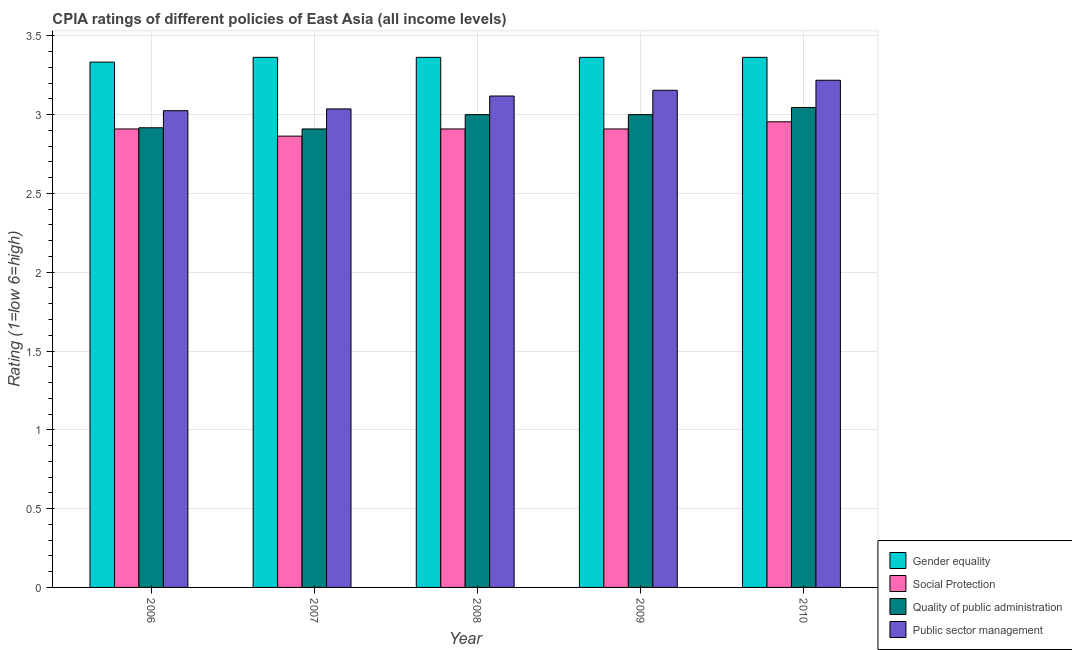How many different coloured bars are there?
Provide a succinct answer. 4. How many groups of bars are there?
Keep it short and to the point. 5. Are the number of bars per tick equal to the number of legend labels?
Ensure brevity in your answer.  Yes. Are the number of bars on each tick of the X-axis equal?
Offer a very short reply. Yes. In how many cases, is the number of bars for a given year not equal to the number of legend labels?
Your answer should be compact. 0. What is the cpia rating of social protection in 2007?
Your answer should be compact. 2.86. Across all years, what is the maximum cpia rating of social protection?
Provide a short and direct response. 2.95. Across all years, what is the minimum cpia rating of public sector management?
Offer a terse response. 3.02. What is the total cpia rating of gender equality in the graph?
Ensure brevity in your answer.  16.79. What is the difference between the cpia rating of social protection in 2006 and that in 2008?
Your response must be concise. 0. What is the difference between the cpia rating of social protection in 2010 and the cpia rating of quality of public administration in 2009?
Ensure brevity in your answer.  0.05. What is the average cpia rating of gender equality per year?
Keep it short and to the point. 3.36. In the year 2007, what is the difference between the cpia rating of public sector management and cpia rating of social protection?
Ensure brevity in your answer.  0. What is the ratio of the cpia rating of social protection in 2006 to that in 2010?
Give a very brief answer. 0.98. Is the cpia rating of gender equality in 2007 less than that in 2010?
Offer a terse response. No. What is the difference between the highest and the second highest cpia rating of gender equality?
Your response must be concise. 0. What is the difference between the highest and the lowest cpia rating of public sector management?
Your answer should be very brief. 0.19. Is the sum of the cpia rating of quality of public administration in 2008 and 2009 greater than the maximum cpia rating of social protection across all years?
Keep it short and to the point. Yes. What does the 1st bar from the left in 2008 represents?
Provide a succinct answer. Gender equality. What does the 1st bar from the right in 2009 represents?
Keep it short and to the point. Public sector management. How many bars are there?
Offer a terse response. 20. What is the difference between two consecutive major ticks on the Y-axis?
Offer a very short reply. 0.5. Does the graph contain grids?
Offer a very short reply. Yes. Where does the legend appear in the graph?
Ensure brevity in your answer.  Bottom right. How are the legend labels stacked?
Give a very brief answer. Vertical. What is the title of the graph?
Provide a succinct answer. CPIA ratings of different policies of East Asia (all income levels). Does "Secondary general education" appear as one of the legend labels in the graph?
Make the answer very short. No. What is the Rating (1=low 6=high) of Gender equality in 2006?
Make the answer very short. 3.33. What is the Rating (1=low 6=high) in Social Protection in 2006?
Offer a very short reply. 2.91. What is the Rating (1=low 6=high) in Quality of public administration in 2006?
Your response must be concise. 2.92. What is the Rating (1=low 6=high) of Public sector management in 2006?
Ensure brevity in your answer.  3.02. What is the Rating (1=low 6=high) of Gender equality in 2007?
Offer a terse response. 3.36. What is the Rating (1=low 6=high) of Social Protection in 2007?
Your response must be concise. 2.86. What is the Rating (1=low 6=high) in Quality of public administration in 2007?
Provide a succinct answer. 2.91. What is the Rating (1=low 6=high) of Public sector management in 2007?
Make the answer very short. 3.04. What is the Rating (1=low 6=high) in Gender equality in 2008?
Your answer should be very brief. 3.36. What is the Rating (1=low 6=high) in Social Protection in 2008?
Offer a terse response. 2.91. What is the Rating (1=low 6=high) of Quality of public administration in 2008?
Your answer should be very brief. 3. What is the Rating (1=low 6=high) of Public sector management in 2008?
Provide a short and direct response. 3.12. What is the Rating (1=low 6=high) in Gender equality in 2009?
Provide a succinct answer. 3.36. What is the Rating (1=low 6=high) of Social Protection in 2009?
Keep it short and to the point. 2.91. What is the Rating (1=low 6=high) in Quality of public administration in 2009?
Your response must be concise. 3. What is the Rating (1=low 6=high) in Public sector management in 2009?
Your response must be concise. 3.15. What is the Rating (1=low 6=high) of Gender equality in 2010?
Offer a very short reply. 3.36. What is the Rating (1=low 6=high) in Social Protection in 2010?
Provide a succinct answer. 2.95. What is the Rating (1=low 6=high) in Quality of public administration in 2010?
Provide a succinct answer. 3.05. What is the Rating (1=low 6=high) of Public sector management in 2010?
Keep it short and to the point. 3.22. Across all years, what is the maximum Rating (1=low 6=high) in Gender equality?
Give a very brief answer. 3.36. Across all years, what is the maximum Rating (1=low 6=high) in Social Protection?
Make the answer very short. 2.95. Across all years, what is the maximum Rating (1=low 6=high) in Quality of public administration?
Ensure brevity in your answer.  3.05. Across all years, what is the maximum Rating (1=low 6=high) in Public sector management?
Your answer should be compact. 3.22. Across all years, what is the minimum Rating (1=low 6=high) in Gender equality?
Make the answer very short. 3.33. Across all years, what is the minimum Rating (1=low 6=high) in Social Protection?
Keep it short and to the point. 2.86. Across all years, what is the minimum Rating (1=low 6=high) of Quality of public administration?
Ensure brevity in your answer.  2.91. Across all years, what is the minimum Rating (1=low 6=high) in Public sector management?
Offer a terse response. 3.02. What is the total Rating (1=low 6=high) of Gender equality in the graph?
Offer a terse response. 16.79. What is the total Rating (1=low 6=high) in Social Protection in the graph?
Ensure brevity in your answer.  14.55. What is the total Rating (1=low 6=high) of Quality of public administration in the graph?
Your answer should be compact. 14.87. What is the total Rating (1=low 6=high) of Public sector management in the graph?
Make the answer very short. 15.55. What is the difference between the Rating (1=low 6=high) in Gender equality in 2006 and that in 2007?
Your answer should be very brief. -0.03. What is the difference between the Rating (1=low 6=high) of Social Protection in 2006 and that in 2007?
Provide a short and direct response. 0.05. What is the difference between the Rating (1=low 6=high) in Quality of public administration in 2006 and that in 2007?
Provide a short and direct response. 0.01. What is the difference between the Rating (1=low 6=high) in Public sector management in 2006 and that in 2007?
Your answer should be very brief. -0.01. What is the difference between the Rating (1=low 6=high) in Gender equality in 2006 and that in 2008?
Make the answer very short. -0.03. What is the difference between the Rating (1=low 6=high) in Quality of public administration in 2006 and that in 2008?
Give a very brief answer. -0.08. What is the difference between the Rating (1=low 6=high) in Public sector management in 2006 and that in 2008?
Provide a succinct answer. -0.09. What is the difference between the Rating (1=low 6=high) in Gender equality in 2006 and that in 2009?
Provide a short and direct response. -0.03. What is the difference between the Rating (1=low 6=high) in Quality of public administration in 2006 and that in 2009?
Your response must be concise. -0.08. What is the difference between the Rating (1=low 6=high) in Public sector management in 2006 and that in 2009?
Give a very brief answer. -0.13. What is the difference between the Rating (1=low 6=high) in Gender equality in 2006 and that in 2010?
Make the answer very short. -0.03. What is the difference between the Rating (1=low 6=high) in Social Protection in 2006 and that in 2010?
Your answer should be compact. -0.05. What is the difference between the Rating (1=low 6=high) in Quality of public administration in 2006 and that in 2010?
Provide a short and direct response. -0.13. What is the difference between the Rating (1=low 6=high) of Public sector management in 2006 and that in 2010?
Your answer should be very brief. -0.19. What is the difference between the Rating (1=low 6=high) in Gender equality in 2007 and that in 2008?
Make the answer very short. 0. What is the difference between the Rating (1=low 6=high) in Social Protection in 2007 and that in 2008?
Your answer should be very brief. -0.05. What is the difference between the Rating (1=low 6=high) of Quality of public administration in 2007 and that in 2008?
Ensure brevity in your answer.  -0.09. What is the difference between the Rating (1=low 6=high) of Public sector management in 2007 and that in 2008?
Offer a terse response. -0.08. What is the difference between the Rating (1=low 6=high) of Social Protection in 2007 and that in 2009?
Offer a terse response. -0.05. What is the difference between the Rating (1=low 6=high) in Quality of public administration in 2007 and that in 2009?
Offer a terse response. -0.09. What is the difference between the Rating (1=low 6=high) in Public sector management in 2007 and that in 2009?
Offer a very short reply. -0.12. What is the difference between the Rating (1=low 6=high) in Gender equality in 2007 and that in 2010?
Provide a succinct answer. 0. What is the difference between the Rating (1=low 6=high) in Social Protection in 2007 and that in 2010?
Your answer should be very brief. -0.09. What is the difference between the Rating (1=low 6=high) of Quality of public administration in 2007 and that in 2010?
Make the answer very short. -0.14. What is the difference between the Rating (1=low 6=high) of Public sector management in 2007 and that in 2010?
Your answer should be compact. -0.18. What is the difference between the Rating (1=low 6=high) in Gender equality in 2008 and that in 2009?
Provide a short and direct response. 0. What is the difference between the Rating (1=low 6=high) of Social Protection in 2008 and that in 2009?
Offer a very short reply. 0. What is the difference between the Rating (1=low 6=high) of Public sector management in 2008 and that in 2009?
Provide a short and direct response. -0.04. What is the difference between the Rating (1=low 6=high) in Gender equality in 2008 and that in 2010?
Keep it short and to the point. 0. What is the difference between the Rating (1=low 6=high) in Social Protection in 2008 and that in 2010?
Make the answer very short. -0.05. What is the difference between the Rating (1=low 6=high) in Quality of public administration in 2008 and that in 2010?
Give a very brief answer. -0.05. What is the difference between the Rating (1=low 6=high) in Public sector management in 2008 and that in 2010?
Provide a short and direct response. -0.1. What is the difference between the Rating (1=low 6=high) of Gender equality in 2009 and that in 2010?
Your response must be concise. 0. What is the difference between the Rating (1=low 6=high) of Social Protection in 2009 and that in 2010?
Provide a succinct answer. -0.05. What is the difference between the Rating (1=low 6=high) of Quality of public administration in 2009 and that in 2010?
Offer a very short reply. -0.05. What is the difference between the Rating (1=low 6=high) in Public sector management in 2009 and that in 2010?
Provide a short and direct response. -0.06. What is the difference between the Rating (1=low 6=high) in Gender equality in 2006 and the Rating (1=low 6=high) in Social Protection in 2007?
Make the answer very short. 0.47. What is the difference between the Rating (1=low 6=high) of Gender equality in 2006 and the Rating (1=low 6=high) of Quality of public administration in 2007?
Offer a very short reply. 0.42. What is the difference between the Rating (1=low 6=high) of Gender equality in 2006 and the Rating (1=low 6=high) of Public sector management in 2007?
Provide a succinct answer. 0.3. What is the difference between the Rating (1=low 6=high) of Social Protection in 2006 and the Rating (1=low 6=high) of Quality of public administration in 2007?
Offer a terse response. 0. What is the difference between the Rating (1=low 6=high) in Social Protection in 2006 and the Rating (1=low 6=high) in Public sector management in 2007?
Keep it short and to the point. -0.13. What is the difference between the Rating (1=low 6=high) of Quality of public administration in 2006 and the Rating (1=low 6=high) of Public sector management in 2007?
Your answer should be very brief. -0.12. What is the difference between the Rating (1=low 6=high) of Gender equality in 2006 and the Rating (1=low 6=high) of Social Protection in 2008?
Ensure brevity in your answer.  0.42. What is the difference between the Rating (1=low 6=high) in Gender equality in 2006 and the Rating (1=low 6=high) in Quality of public administration in 2008?
Give a very brief answer. 0.33. What is the difference between the Rating (1=low 6=high) of Gender equality in 2006 and the Rating (1=low 6=high) of Public sector management in 2008?
Give a very brief answer. 0.22. What is the difference between the Rating (1=low 6=high) in Social Protection in 2006 and the Rating (1=low 6=high) in Quality of public administration in 2008?
Your answer should be very brief. -0.09. What is the difference between the Rating (1=low 6=high) of Social Protection in 2006 and the Rating (1=low 6=high) of Public sector management in 2008?
Make the answer very short. -0.21. What is the difference between the Rating (1=low 6=high) in Quality of public administration in 2006 and the Rating (1=low 6=high) in Public sector management in 2008?
Your response must be concise. -0.2. What is the difference between the Rating (1=low 6=high) in Gender equality in 2006 and the Rating (1=low 6=high) in Social Protection in 2009?
Your answer should be compact. 0.42. What is the difference between the Rating (1=low 6=high) of Gender equality in 2006 and the Rating (1=low 6=high) of Public sector management in 2009?
Your answer should be compact. 0.18. What is the difference between the Rating (1=low 6=high) in Social Protection in 2006 and the Rating (1=low 6=high) in Quality of public administration in 2009?
Offer a terse response. -0.09. What is the difference between the Rating (1=low 6=high) of Social Protection in 2006 and the Rating (1=low 6=high) of Public sector management in 2009?
Your response must be concise. -0.25. What is the difference between the Rating (1=low 6=high) in Quality of public administration in 2006 and the Rating (1=low 6=high) in Public sector management in 2009?
Your response must be concise. -0.24. What is the difference between the Rating (1=low 6=high) in Gender equality in 2006 and the Rating (1=low 6=high) in Social Protection in 2010?
Your response must be concise. 0.38. What is the difference between the Rating (1=low 6=high) in Gender equality in 2006 and the Rating (1=low 6=high) in Quality of public administration in 2010?
Your answer should be compact. 0.29. What is the difference between the Rating (1=low 6=high) in Gender equality in 2006 and the Rating (1=low 6=high) in Public sector management in 2010?
Offer a very short reply. 0.12. What is the difference between the Rating (1=low 6=high) of Social Protection in 2006 and the Rating (1=low 6=high) of Quality of public administration in 2010?
Make the answer very short. -0.14. What is the difference between the Rating (1=low 6=high) of Social Protection in 2006 and the Rating (1=low 6=high) of Public sector management in 2010?
Your answer should be very brief. -0.31. What is the difference between the Rating (1=low 6=high) in Quality of public administration in 2006 and the Rating (1=low 6=high) in Public sector management in 2010?
Your answer should be very brief. -0.3. What is the difference between the Rating (1=low 6=high) in Gender equality in 2007 and the Rating (1=low 6=high) in Social Protection in 2008?
Provide a succinct answer. 0.45. What is the difference between the Rating (1=low 6=high) of Gender equality in 2007 and the Rating (1=low 6=high) of Quality of public administration in 2008?
Ensure brevity in your answer.  0.36. What is the difference between the Rating (1=low 6=high) of Gender equality in 2007 and the Rating (1=low 6=high) of Public sector management in 2008?
Your answer should be compact. 0.25. What is the difference between the Rating (1=low 6=high) of Social Protection in 2007 and the Rating (1=low 6=high) of Quality of public administration in 2008?
Keep it short and to the point. -0.14. What is the difference between the Rating (1=low 6=high) in Social Protection in 2007 and the Rating (1=low 6=high) in Public sector management in 2008?
Make the answer very short. -0.25. What is the difference between the Rating (1=low 6=high) in Quality of public administration in 2007 and the Rating (1=low 6=high) in Public sector management in 2008?
Offer a very short reply. -0.21. What is the difference between the Rating (1=low 6=high) of Gender equality in 2007 and the Rating (1=low 6=high) of Social Protection in 2009?
Keep it short and to the point. 0.45. What is the difference between the Rating (1=low 6=high) of Gender equality in 2007 and the Rating (1=low 6=high) of Quality of public administration in 2009?
Your response must be concise. 0.36. What is the difference between the Rating (1=low 6=high) in Gender equality in 2007 and the Rating (1=low 6=high) in Public sector management in 2009?
Your answer should be compact. 0.21. What is the difference between the Rating (1=low 6=high) in Social Protection in 2007 and the Rating (1=low 6=high) in Quality of public administration in 2009?
Offer a very short reply. -0.14. What is the difference between the Rating (1=low 6=high) of Social Protection in 2007 and the Rating (1=low 6=high) of Public sector management in 2009?
Offer a very short reply. -0.29. What is the difference between the Rating (1=low 6=high) of Quality of public administration in 2007 and the Rating (1=low 6=high) of Public sector management in 2009?
Provide a short and direct response. -0.25. What is the difference between the Rating (1=low 6=high) of Gender equality in 2007 and the Rating (1=low 6=high) of Social Protection in 2010?
Provide a short and direct response. 0.41. What is the difference between the Rating (1=low 6=high) of Gender equality in 2007 and the Rating (1=low 6=high) of Quality of public administration in 2010?
Ensure brevity in your answer.  0.32. What is the difference between the Rating (1=low 6=high) in Gender equality in 2007 and the Rating (1=low 6=high) in Public sector management in 2010?
Keep it short and to the point. 0.15. What is the difference between the Rating (1=low 6=high) in Social Protection in 2007 and the Rating (1=low 6=high) in Quality of public administration in 2010?
Keep it short and to the point. -0.18. What is the difference between the Rating (1=low 6=high) of Social Protection in 2007 and the Rating (1=low 6=high) of Public sector management in 2010?
Your answer should be compact. -0.35. What is the difference between the Rating (1=low 6=high) in Quality of public administration in 2007 and the Rating (1=low 6=high) in Public sector management in 2010?
Offer a terse response. -0.31. What is the difference between the Rating (1=low 6=high) of Gender equality in 2008 and the Rating (1=low 6=high) of Social Protection in 2009?
Give a very brief answer. 0.45. What is the difference between the Rating (1=low 6=high) of Gender equality in 2008 and the Rating (1=low 6=high) of Quality of public administration in 2009?
Provide a succinct answer. 0.36. What is the difference between the Rating (1=low 6=high) of Gender equality in 2008 and the Rating (1=low 6=high) of Public sector management in 2009?
Keep it short and to the point. 0.21. What is the difference between the Rating (1=low 6=high) in Social Protection in 2008 and the Rating (1=low 6=high) in Quality of public administration in 2009?
Offer a terse response. -0.09. What is the difference between the Rating (1=low 6=high) of Social Protection in 2008 and the Rating (1=low 6=high) of Public sector management in 2009?
Your answer should be compact. -0.25. What is the difference between the Rating (1=low 6=high) in Quality of public administration in 2008 and the Rating (1=low 6=high) in Public sector management in 2009?
Ensure brevity in your answer.  -0.15. What is the difference between the Rating (1=low 6=high) in Gender equality in 2008 and the Rating (1=low 6=high) in Social Protection in 2010?
Provide a short and direct response. 0.41. What is the difference between the Rating (1=low 6=high) in Gender equality in 2008 and the Rating (1=low 6=high) in Quality of public administration in 2010?
Give a very brief answer. 0.32. What is the difference between the Rating (1=low 6=high) of Gender equality in 2008 and the Rating (1=low 6=high) of Public sector management in 2010?
Your answer should be compact. 0.15. What is the difference between the Rating (1=low 6=high) of Social Protection in 2008 and the Rating (1=low 6=high) of Quality of public administration in 2010?
Keep it short and to the point. -0.14. What is the difference between the Rating (1=low 6=high) of Social Protection in 2008 and the Rating (1=low 6=high) of Public sector management in 2010?
Offer a terse response. -0.31. What is the difference between the Rating (1=low 6=high) in Quality of public administration in 2008 and the Rating (1=low 6=high) in Public sector management in 2010?
Your answer should be very brief. -0.22. What is the difference between the Rating (1=low 6=high) of Gender equality in 2009 and the Rating (1=low 6=high) of Social Protection in 2010?
Make the answer very short. 0.41. What is the difference between the Rating (1=low 6=high) in Gender equality in 2009 and the Rating (1=low 6=high) in Quality of public administration in 2010?
Your answer should be compact. 0.32. What is the difference between the Rating (1=low 6=high) of Gender equality in 2009 and the Rating (1=low 6=high) of Public sector management in 2010?
Your response must be concise. 0.15. What is the difference between the Rating (1=low 6=high) of Social Protection in 2009 and the Rating (1=low 6=high) of Quality of public administration in 2010?
Give a very brief answer. -0.14. What is the difference between the Rating (1=low 6=high) in Social Protection in 2009 and the Rating (1=low 6=high) in Public sector management in 2010?
Your answer should be compact. -0.31. What is the difference between the Rating (1=low 6=high) of Quality of public administration in 2009 and the Rating (1=low 6=high) of Public sector management in 2010?
Ensure brevity in your answer.  -0.22. What is the average Rating (1=low 6=high) in Gender equality per year?
Make the answer very short. 3.36. What is the average Rating (1=low 6=high) of Social Protection per year?
Offer a very short reply. 2.91. What is the average Rating (1=low 6=high) of Quality of public administration per year?
Ensure brevity in your answer.  2.97. What is the average Rating (1=low 6=high) in Public sector management per year?
Your answer should be compact. 3.11. In the year 2006, what is the difference between the Rating (1=low 6=high) of Gender equality and Rating (1=low 6=high) of Social Protection?
Ensure brevity in your answer.  0.42. In the year 2006, what is the difference between the Rating (1=low 6=high) of Gender equality and Rating (1=low 6=high) of Quality of public administration?
Give a very brief answer. 0.42. In the year 2006, what is the difference between the Rating (1=low 6=high) in Gender equality and Rating (1=low 6=high) in Public sector management?
Your answer should be very brief. 0.31. In the year 2006, what is the difference between the Rating (1=low 6=high) of Social Protection and Rating (1=low 6=high) of Quality of public administration?
Give a very brief answer. -0.01. In the year 2006, what is the difference between the Rating (1=low 6=high) in Social Protection and Rating (1=low 6=high) in Public sector management?
Keep it short and to the point. -0.12. In the year 2006, what is the difference between the Rating (1=low 6=high) in Quality of public administration and Rating (1=low 6=high) in Public sector management?
Your response must be concise. -0.11. In the year 2007, what is the difference between the Rating (1=low 6=high) in Gender equality and Rating (1=low 6=high) in Social Protection?
Ensure brevity in your answer.  0.5. In the year 2007, what is the difference between the Rating (1=low 6=high) in Gender equality and Rating (1=low 6=high) in Quality of public administration?
Ensure brevity in your answer.  0.45. In the year 2007, what is the difference between the Rating (1=low 6=high) of Gender equality and Rating (1=low 6=high) of Public sector management?
Make the answer very short. 0.33. In the year 2007, what is the difference between the Rating (1=low 6=high) in Social Protection and Rating (1=low 6=high) in Quality of public administration?
Your answer should be very brief. -0.05. In the year 2007, what is the difference between the Rating (1=low 6=high) in Social Protection and Rating (1=low 6=high) in Public sector management?
Provide a succinct answer. -0.17. In the year 2007, what is the difference between the Rating (1=low 6=high) of Quality of public administration and Rating (1=low 6=high) of Public sector management?
Your answer should be compact. -0.13. In the year 2008, what is the difference between the Rating (1=low 6=high) in Gender equality and Rating (1=low 6=high) in Social Protection?
Keep it short and to the point. 0.45. In the year 2008, what is the difference between the Rating (1=low 6=high) in Gender equality and Rating (1=low 6=high) in Quality of public administration?
Your response must be concise. 0.36. In the year 2008, what is the difference between the Rating (1=low 6=high) of Gender equality and Rating (1=low 6=high) of Public sector management?
Provide a short and direct response. 0.25. In the year 2008, what is the difference between the Rating (1=low 6=high) in Social Protection and Rating (1=low 6=high) in Quality of public administration?
Provide a short and direct response. -0.09. In the year 2008, what is the difference between the Rating (1=low 6=high) in Social Protection and Rating (1=low 6=high) in Public sector management?
Your response must be concise. -0.21. In the year 2008, what is the difference between the Rating (1=low 6=high) in Quality of public administration and Rating (1=low 6=high) in Public sector management?
Your answer should be very brief. -0.12. In the year 2009, what is the difference between the Rating (1=low 6=high) in Gender equality and Rating (1=low 6=high) in Social Protection?
Offer a very short reply. 0.45. In the year 2009, what is the difference between the Rating (1=low 6=high) in Gender equality and Rating (1=low 6=high) in Quality of public administration?
Make the answer very short. 0.36. In the year 2009, what is the difference between the Rating (1=low 6=high) of Gender equality and Rating (1=low 6=high) of Public sector management?
Keep it short and to the point. 0.21. In the year 2009, what is the difference between the Rating (1=low 6=high) of Social Protection and Rating (1=low 6=high) of Quality of public administration?
Your response must be concise. -0.09. In the year 2009, what is the difference between the Rating (1=low 6=high) of Social Protection and Rating (1=low 6=high) of Public sector management?
Your response must be concise. -0.25. In the year 2009, what is the difference between the Rating (1=low 6=high) of Quality of public administration and Rating (1=low 6=high) of Public sector management?
Offer a terse response. -0.15. In the year 2010, what is the difference between the Rating (1=low 6=high) of Gender equality and Rating (1=low 6=high) of Social Protection?
Make the answer very short. 0.41. In the year 2010, what is the difference between the Rating (1=low 6=high) in Gender equality and Rating (1=low 6=high) in Quality of public administration?
Make the answer very short. 0.32. In the year 2010, what is the difference between the Rating (1=low 6=high) in Gender equality and Rating (1=low 6=high) in Public sector management?
Provide a short and direct response. 0.15. In the year 2010, what is the difference between the Rating (1=low 6=high) in Social Protection and Rating (1=low 6=high) in Quality of public administration?
Provide a succinct answer. -0.09. In the year 2010, what is the difference between the Rating (1=low 6=high) in Social Protection and Rating (1=low 6=high) in Public sector management?
Offer a terse response. -0.26. In the year 2010, what is the difference between the Rating (1=low 6=high) of Quality of public administration and Rating (1=low 6=high) of Public sector management?
Provide a short and direct response. -0.17. What is the ratio of the Rating (1=low 6=high) in Gender equality in 2006 to that in 2007?
Offer a terse response. 0.99. What is the ratio of the Rating (1=low 6=high) in Social Protection in 2006 to that in 2007?
Ensure brevity in your answer.  1.02. What is the ratio of the Rating (1=low 6=high) in Quality of public administration in 2006 to that in 2007?
Provide a short and direct response. 1. What is the ratio of the Rating (1=low 6=high) in Quality of public administration in 2006 to that in 2008?
Your response must be concise. 0.97. What is the ratio of the Rating (1=low 6=high) in Public sector management in 2006 to that in 2008?
Your answer should be very brief. 0.97. What is the ratio of the Rating (1=low 6=high) of Quality of public administration in 2006 to that in 2009?
Give a very brief answer. 0.97. What is the ratio of the Rating (1=low 6=high) of Public sector management in 2006 to that in 2009?
Your answer should be compact. 0.96. What is the ratio of the Rating (1=low 6=high) in Gender equality in 2006 to that in 2010?
Ensure brevity in your answer.  0.99. What is the ratio of the Rating (1=low 6=high) in Social Protection in 2006 to that in 2010?
Provide a short and direct response. 0.98. What is the ratio of the Rating (1=low 6=high) in Quality of public administration in 2006 to that in 2010?
Provide a succinct answer. 0.96. What is the ratio of the Rating (1=low 6=high) in Public sector management in 2006 to that in 2010?
Ensure brevity in your answer.  0.94. What is the ratio of the Rating (1=low 6=high) of Social Protection in 2007 to that in 2008?
Provide a short and direct response. 0.98. What is the ratio of the Rating (1=low 6=high) of Quality of public administration in 2007 to that in 2008?
Give a very brief answer. 0.97. What is the ratio of the Rating (1=low 6=high) in Public sector management in 2007 to that in 2008?
Provide a short and direct response. 0.97. What is the ratio of the Rating (1=low 6=high) in Gender equality in 2007 to that in 2009?
Offer a very short reply. 1. What is the ratio of the Rating (1=low 6=high) of Social Protection in 2007 to that in 2009?
Offer a very short reply. 0.98. What is the ratio of the Rating (1=low 6=high) of Quality of public administration in 2007 to that in 2009?
Your answer should be very brief. 0.97. What is the ratio of the Rating (1=low 6=high) in Public sector management in 2007 to that in 2009?
Provide a short and direct response. 0.96. What is the ratio of the Rating (1=low 6=high) in Gender equality in 2007 to that in 2010?
Make the answer very short. 1. What is the ratio of the Rating (1=low 6=high) of Social Protection in 2007 to that in 2010?
Provide a short and direct response. 0.97. What is the ratio of the Rating (1=low 6=high) in Quality of public administration in 2007 to that in 2010?
Provide a short and direct response. 0.96. What is the ratio of the Rating (1=low 6=high) of Public sector management in 2007 to that in 2010?
Your answer should be very brief. 0.94. What is the ratio of the Rating (1=low 6=high) in Social Protection in 2008 to that in 2009?
Make the answer very short. 1. What is the ratio of the Rating (1=low 6=high) in Quality of public administration in 2008 to that in 2009?
Your response must be concise. 1. What is the ratio of the Rating (1=low 6=high) of Social Protection in 2008 to that in 2010?
Your answer should be very brief. 0.98. What is the ratio of the Rating (1=low 6=high) in Quality of public administration in 2008 to that in 2010?
Your response must be concise. 0.99. What is the ratio of the Rating (1=low 6=high) of Public sector management in 2008 to that in 2010?
Your answer should be compact. 0.97. What is the ratio of the Rating (1=low 6=high) of Gender equality in 2009 to that in 2010?
Give a very brief answer. 1. What is the ratio of the Rating (1=low 6=high) of Social Protection in 2009 to that in 2010?
Your answer should be compact. 0.98. What is the ratio of the Rating (1=low 6=high) of Quality of public administration in 2009 to that in 2010?
Offer a terse response. 0.99. What is the ratio of the Rating (1=low 6=high) in Public sector management in 2009 to that in 2010?
Provide a short and direct response. 0.98. What is the difference between the highest and the second highest Rating (1=low 6=high) in Social Protection?
Keep it short and to the point. 0.05. What is the difference between the highest and the second highest Rating (1=low 6=high) in Quality of public administration?
Keep it short and to the point. 0.05. What is the difference between the highest and the second highest Rating (1=low 6=high) in Public sector management?
Give a very brief answer. 0.06. What is the difference between the highest and the lowest Rating (1=low 6=high) in Gender equality?
Your response must be concise. 0.03. What is the difference between the highest and the lowest Rating (1=low 6=high) in Social Protection?
Provide a succinct answer. 0.09. What is the difference between the highest and the lowest Rating (1=low 6=high) of Quality of public administration?
Your answer should be very brief. 0.14. What is the difference between the highest and the lowest Rating (1=low 6=high) in Public sector management?
Provide a succinct answer. 0.19. 